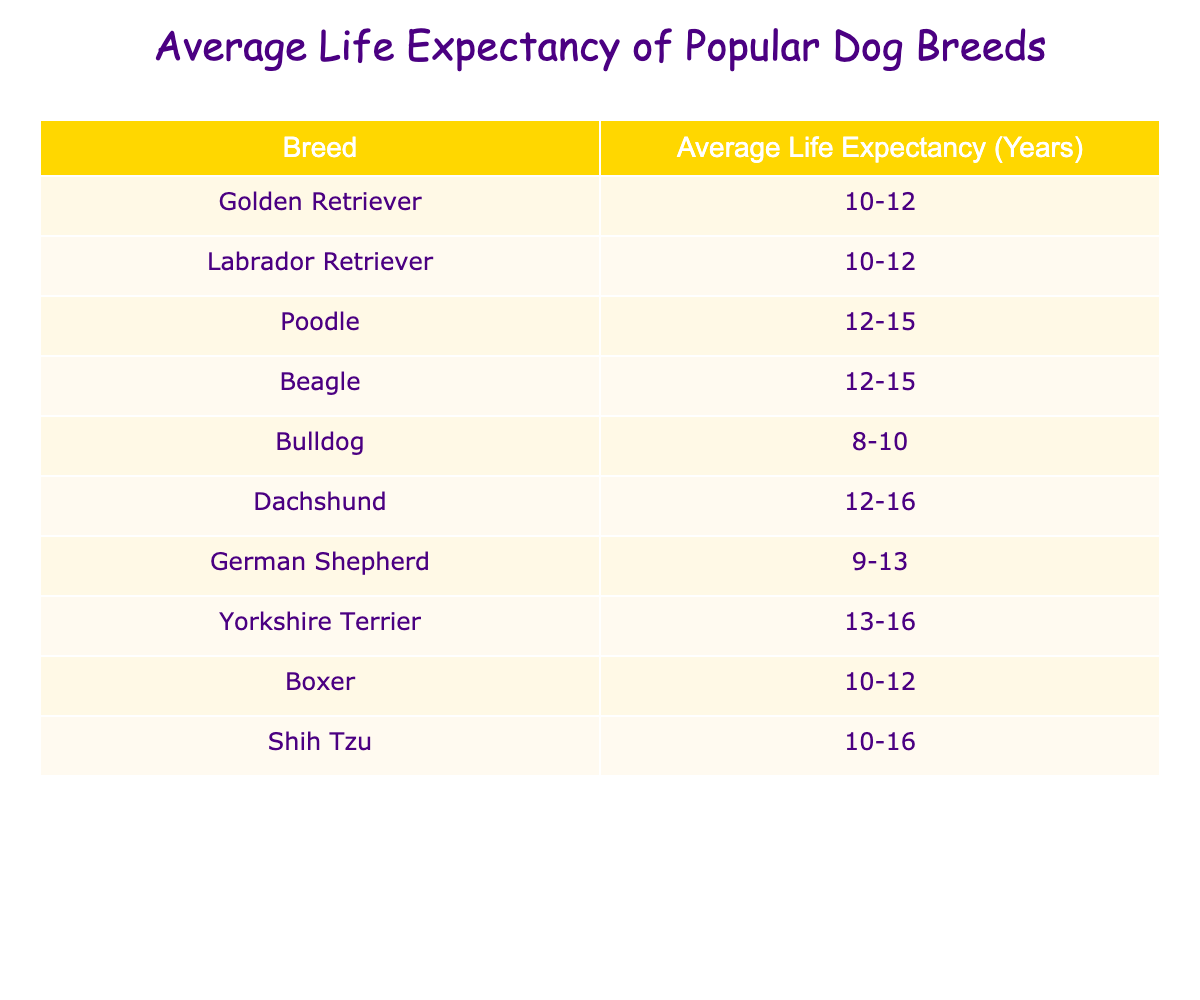What is the average life expectancy of a Golden Retriever? The table shows that the average life expectancy of a Golden Retriever is listed as 10-12 years.
Answer: 10-12 years Which breed has the longest average life expectancy? From the table, the Yorkshire Terrier has the longest average life expectancy of 13-16 years.
Answer: Yorkshire Terrier: 13-16 years True or False: Bulldogs have a longer average life expectancy than Dachshunds. Referring to the table, Bulldogs have an average life expectancy of 8-10 years, while Dachshunds have 12-16 years. Since 8-10 is less than 12-16, the statement is false.
Answer: False What is the average life expectancy of a Labrador Retriever compared to a Beagle? Both the Labrador Retriever and Beagle have an average life expectancy of 10-12 and 12-15 years, respectively. Since 12-15 years is greater than 10-12 years, the Beagle has a longer life expectancy than the Labrador Retriever.
Answer: Beagle: 12-15 years (longer) If you combined the average life expectancies of Poodles and Boxers, what would that be? The average life expectancy for Poodles is 12-15 years and for Boxers, it is 10-12 years. To find the combined average lifespan, we notice that 12-15 has a midpoint of 13.5 years and 10-12 has a midpoint of 11 years. So, (13.5 + 11) / 2 = approximately 12.25 years.
Answer: Approximately 12.25 years Which two breeds have the same average life expectancy? Looking at the table, both Golden Retrievers and Labrador Retrievers have the same average life expectancy range of 10-12 years.
Answer: Golden Retriever and Labrador Retriever What is the difference in average life expectancy between a Shih Tzu and a Bulldog? The Shih Tzu has an average life expectancy of 10-16 years while the Bulldog has 8-10 years. To analyze this difference, we consider the midpoints: Shih Tzu (13) and Bulldog (9). The difference is 13 - 9 = 4 years.
Answer: 4 years How many breeds have an average life expectancy of less than 10 years? The table indicates that Bulldogs (8-10 years) are the only breed with a maximum life expectancy less than 10 years. Hence, there is one breed in this category.
Answer: 1 breed 